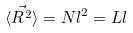Convert formula to latex. <formula><loc_0><loc_0><loc_500><loc_500>\langle \vec { R ^ { 2 } } \rangle = N l ^ { 2 } = L l</formula> 